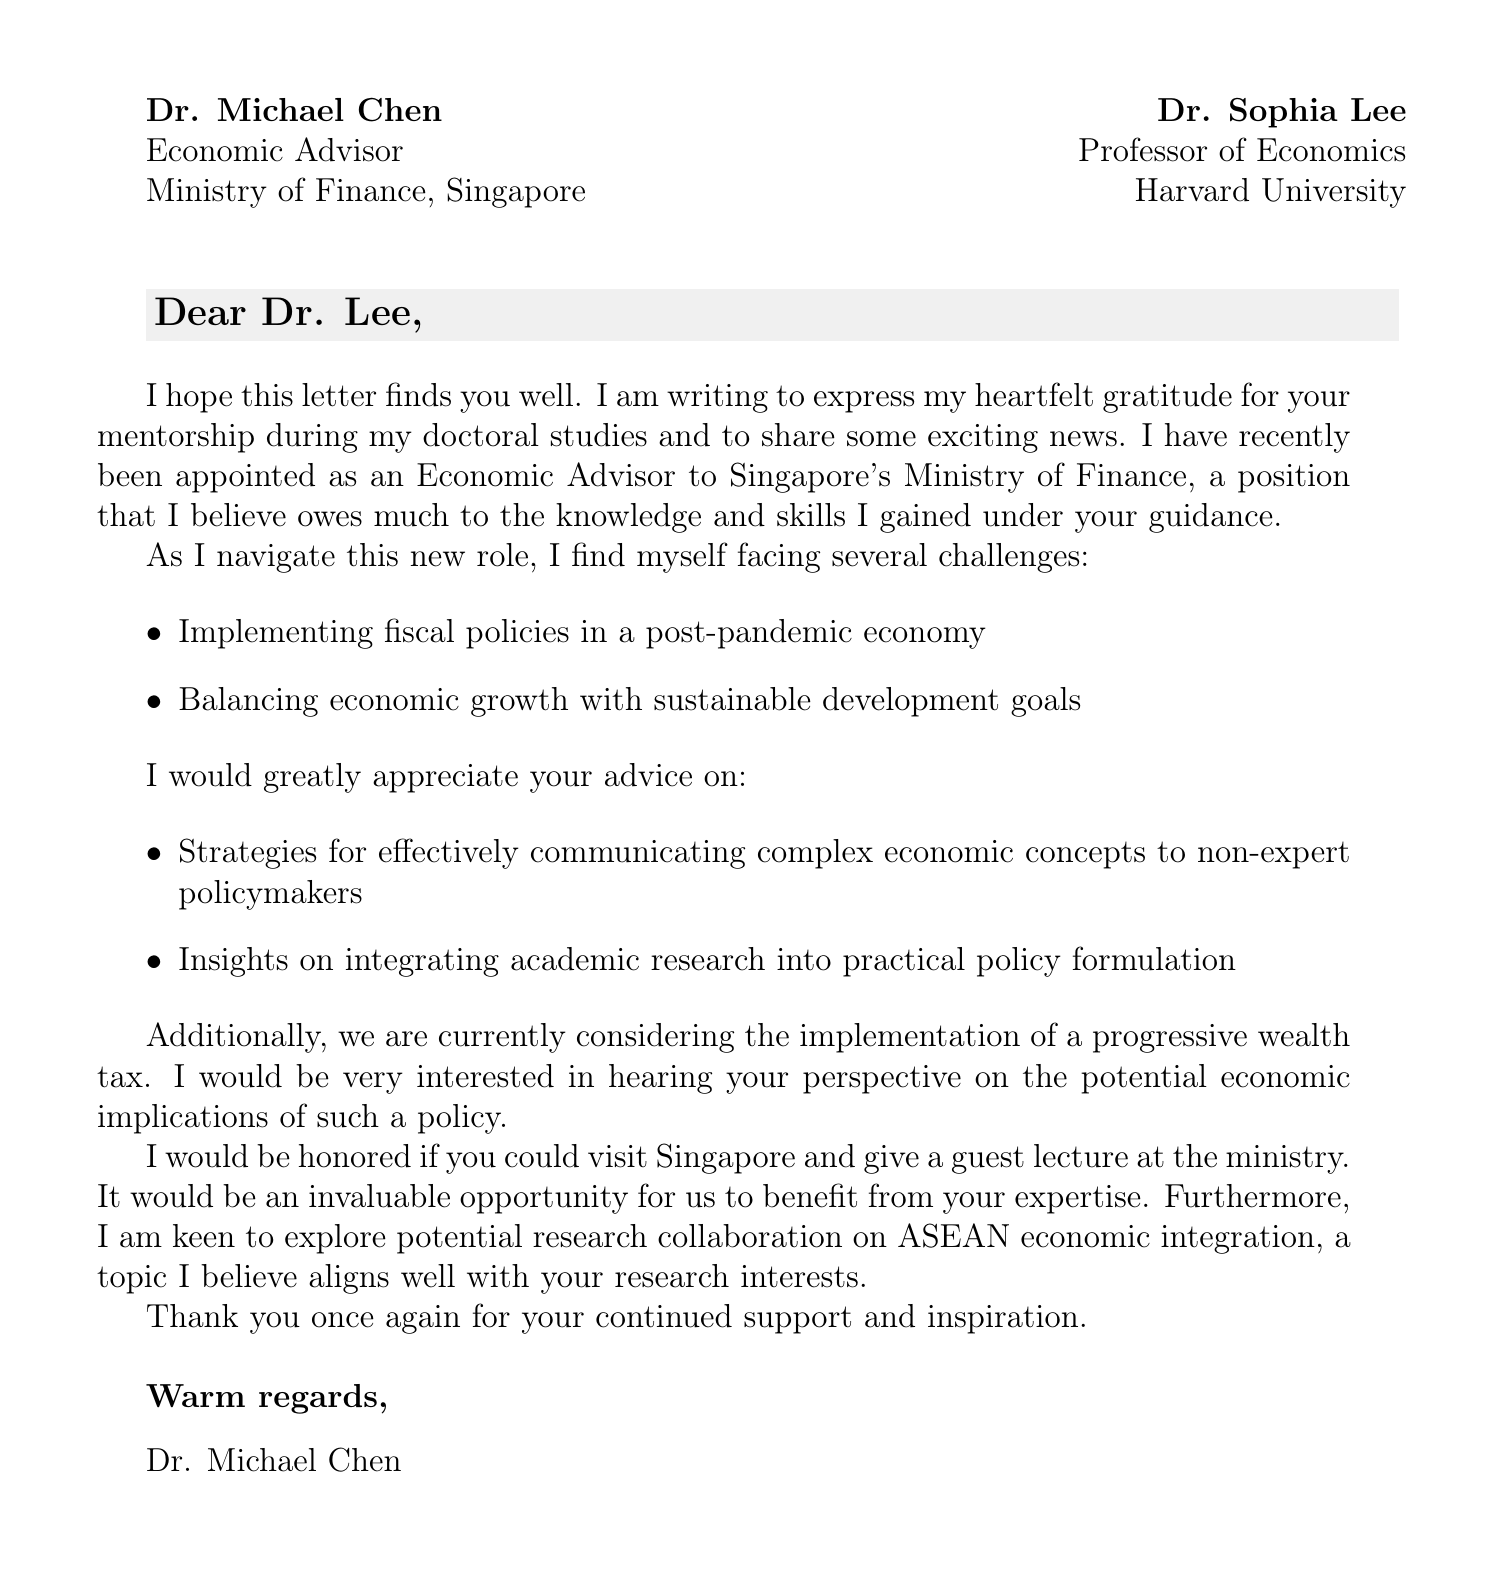What is Dr. Michael Chen's current position? Dr. Michael Chen states that he is the Economic Advisor to Singapore's Ministry of Finance.
Answer: Economic Advisor Who is Dr. Chen addressing the letter to? The letter is addressed to Dr. Sophia Lee, who is a Professor of Economics at Harvard University.
Answer: Dr. Sophia Lee What major policy topic is Dr. Chen seeking advice on? Dr. Chen is seeking Dr. Lee's perspective on the proposed implementation of a progressive wealth tax.
Answer: Progressive wealth tax What challenges is Dr. Chen facing in his new role? The challenges listed include navigating fiscal policy implementation in a post-pandemic economy and balancing economic growth with sustainable development goals.
Answer: Complexities of fiscal policy implementation, balancing growth with sustainability What is the invitation extended to Dr. Lee? Dr. Chen invites Dr. Lee to visit Singapore and give a guest lecture at the ministry.
Answer: Guest lecture at the ministry What does Dr. Chen express interest in regarding future work with Dr. Lee? Dr. Chen expresses interest in potential research collaboration on ASEAN economic integration.
Answer: Research collaboration on ASEAN economic integration How does Dr. Chen sign off in the letter? The letter is signed off with "Warm regards."
Answer: Warm regards What does Dr. Chen thank Dr. Lee for in the letter? Dr. Chen expresses heartfelt gratitude for Dr. Lee's mentorship during his doctoral studies.
Answer: Mentorship during doctoral studies 